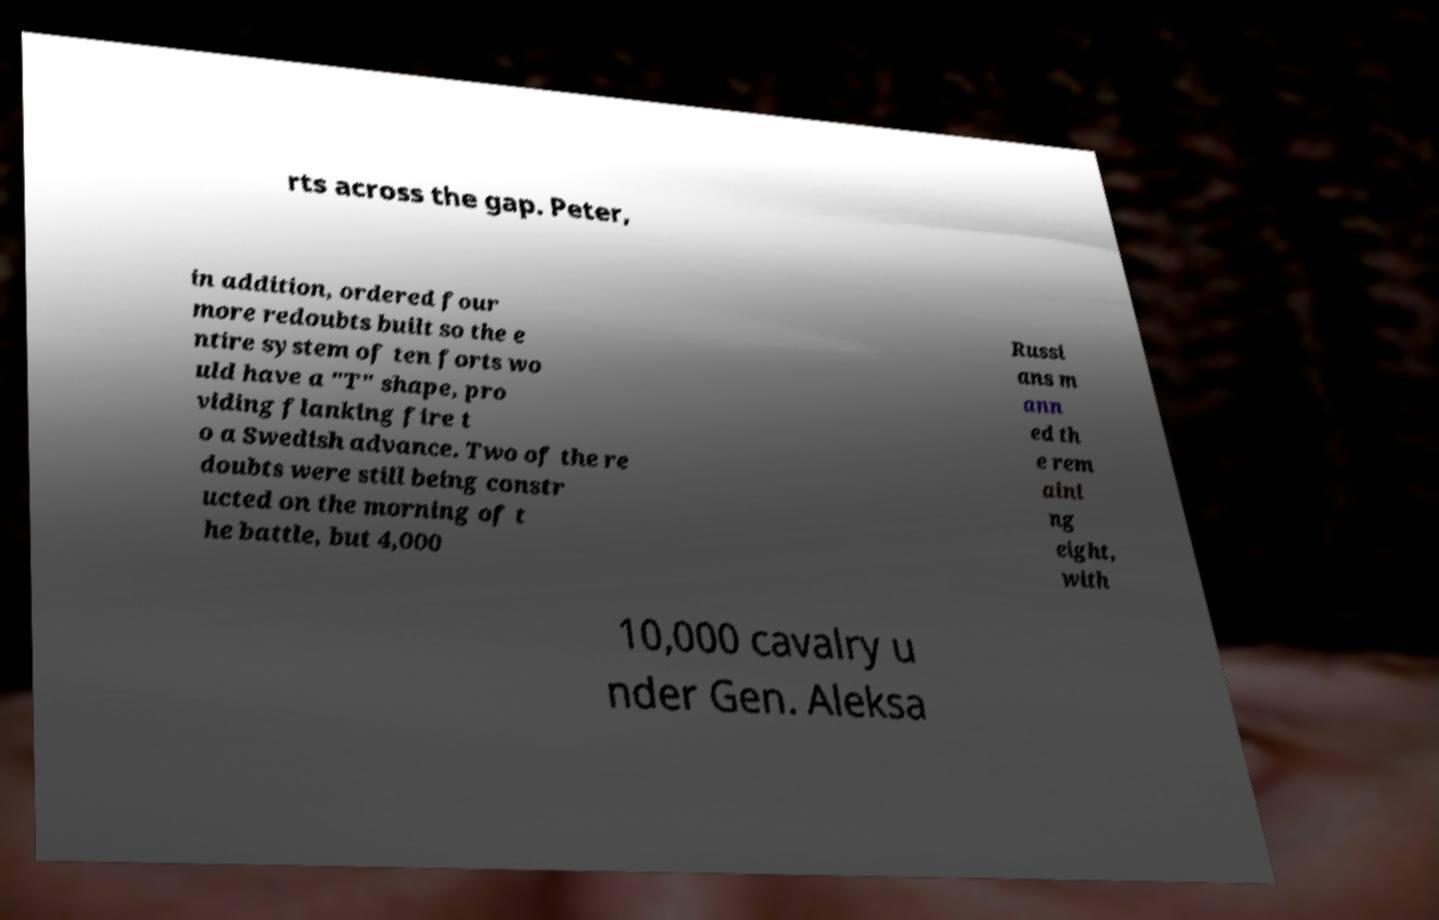Can you read and provide the text displayed in the image?This photo seems to have some interesting text. Can you extract and type it out for me? rts across the gap. Peter, in addition, ordered four more redoubts built so the e ntire system of ten forts wo uld have a "T" shape, pro viding flanking fire t o a Swedish advance. Two of the re doubts were still being constr ucted on the morning of t he battle, but 4,000 Russi ans m ann ed th e rem aini ng eight, with 10,000 cavalry u nder Gen. Aleksa 